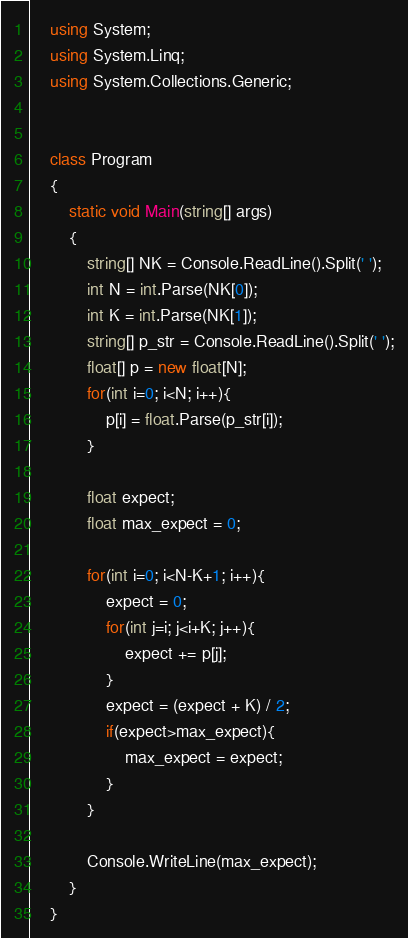<code> <loc_0><loc_0><loc_500><loc_500><_C#_>    using System;
    using System.Linq;
    using System.Collections.Generic;


    class Program
    {
        static void Main(string[] args)
        {
            string[] NK = Console.ReadLine().Split(' ');
            int N = int.Parse(NK[0]);
            int K = int.Parse(NK[1]);
            string[] p_str = Console.ReadLine().Split(' ');
            float[] p = new float[N];
            for(int i=0; i<N; i++){
                p[i] = float.Parse(p_str[i]);
            }

            float expect;
            float max_expect = 0;

            for(int i=0; i<N-K+1; i++){
                expect = 0;
                for(int j=i; j<i+K; j++){
                    expect += p[j];
                }
                expect = (expect + K) / 2;
                if(expect>max_expect){
                    max_expect = expect;
                }
            }

            Console.WriteLine(max_expect);
        }
    }</code> 